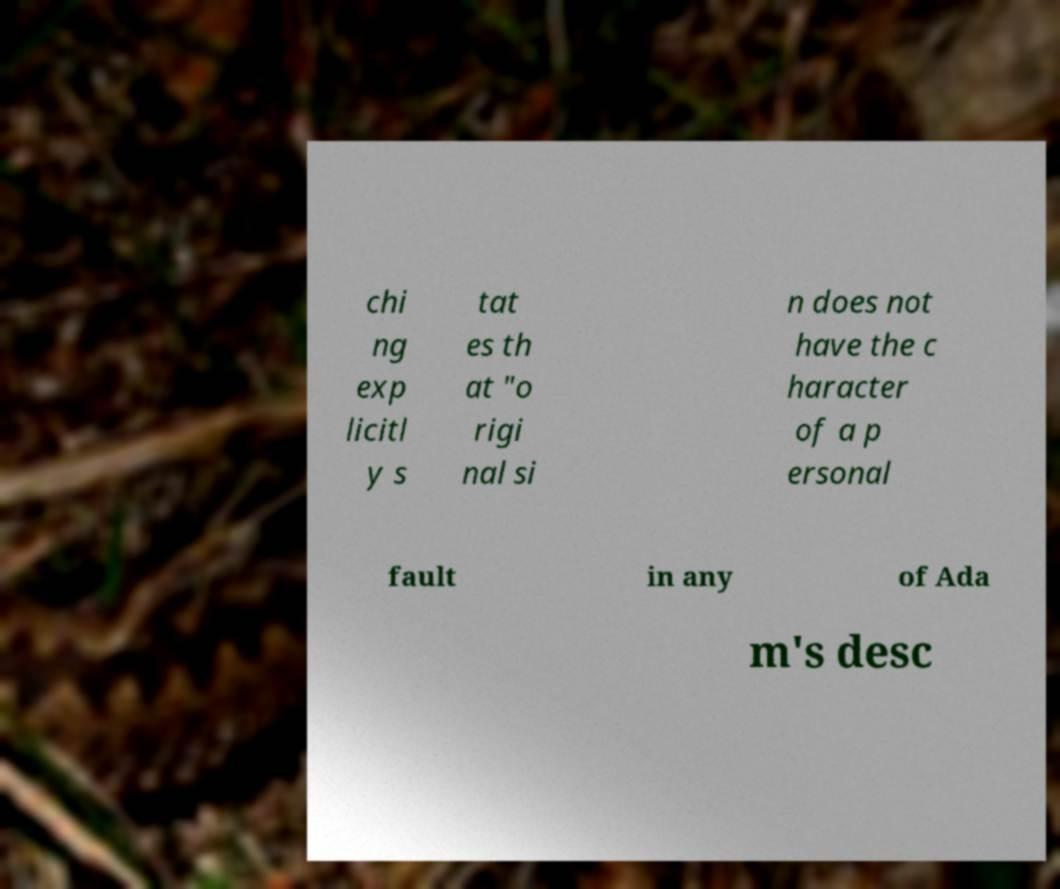For documentation purposes, I need the text within this image transcribed. Could you provide that? chi ng exp licitl y s tat es th at "o rigi nal si n does not have the c haracter of a p ersonal fault in any of Ada m's desc 